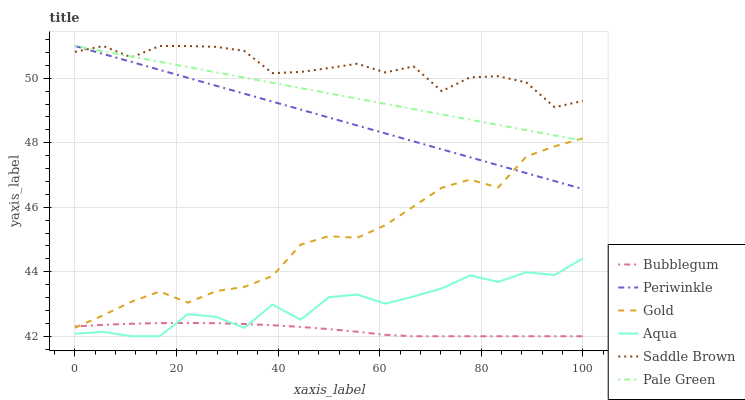Does Bubblegum have the minimum area under the curve?
Answer yes or no. Yes. Does Saddle Brown have the maximum area under the curve?
Answer yes or no. Yes. Does Aqua have the minimum area under the curve?
Answer yes or no. No. Does Aqua have the maximum area under the curve?
Answer yes or no. No. Is Periwinkle the smoothest?
Answer yes or no. Yes. Is Aqua the roughest?
Answer yes or no. Yes. Is Bubblegum the smoothest?
Answer yes or no. No. Is Bubblegum the roughest?
Answer yes or no. No. Does Aqua have the lowest value?
Answer yes or no. Yes. Does Pale Green have the lowest value?
Answer yes or no. No. Does Saddle Brown have the highest value?
Answer yes or no. Yes. Does Aqua have the highest value?
Answer yes or no. No. Is Bubblegum less than Periwinkle?
Answer yes or no. Yes. Is Pale Green greater than Bubblegum?
Answer yes or no. Yes. Does Periwinkle intersect Gold?
Answer yes or no. Yes. Is Periwinkle less than Gold?
Answer yes or no. No. Is Periwinkle greater than Gold?
Answer yes or no. No. Does Bubblegum intersect Periwinkle?
Answer yes or no. No. 